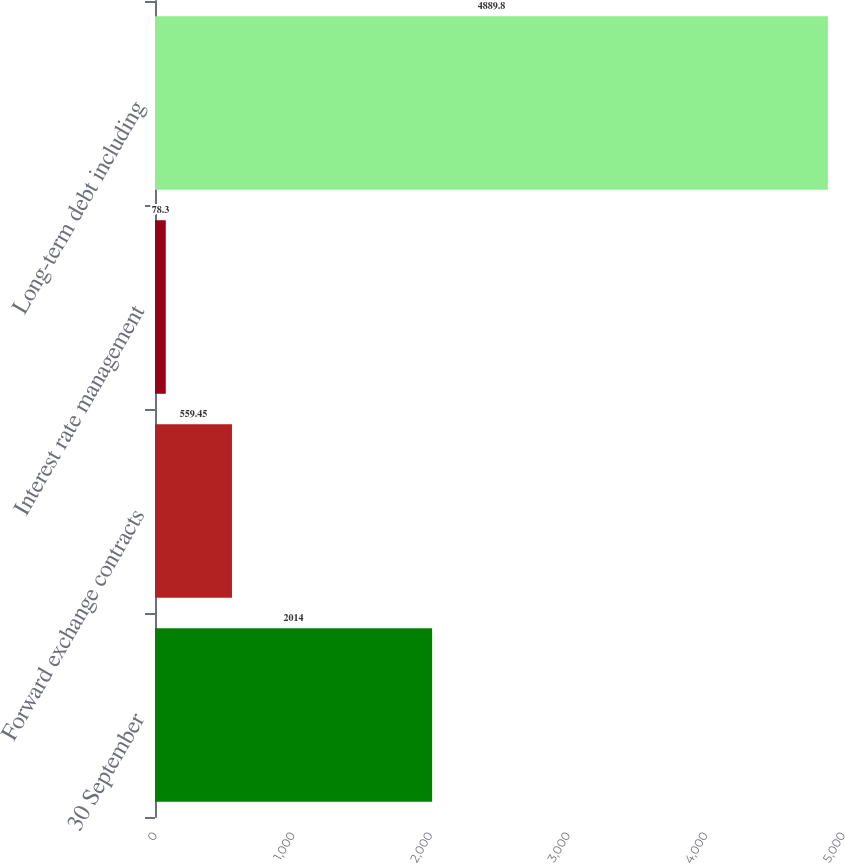Convert chart. <chart><loc_0><loc_0><loc_500><loc_500><bar_chart><fcel>30 September<fcel>Forward exchange contracts<fcel>Interest rate management<fcel>Long-term debt including<nl><fcel>2014<fcel>559.45<fcel>78.3<fcel>4889.8<nl></chart> 